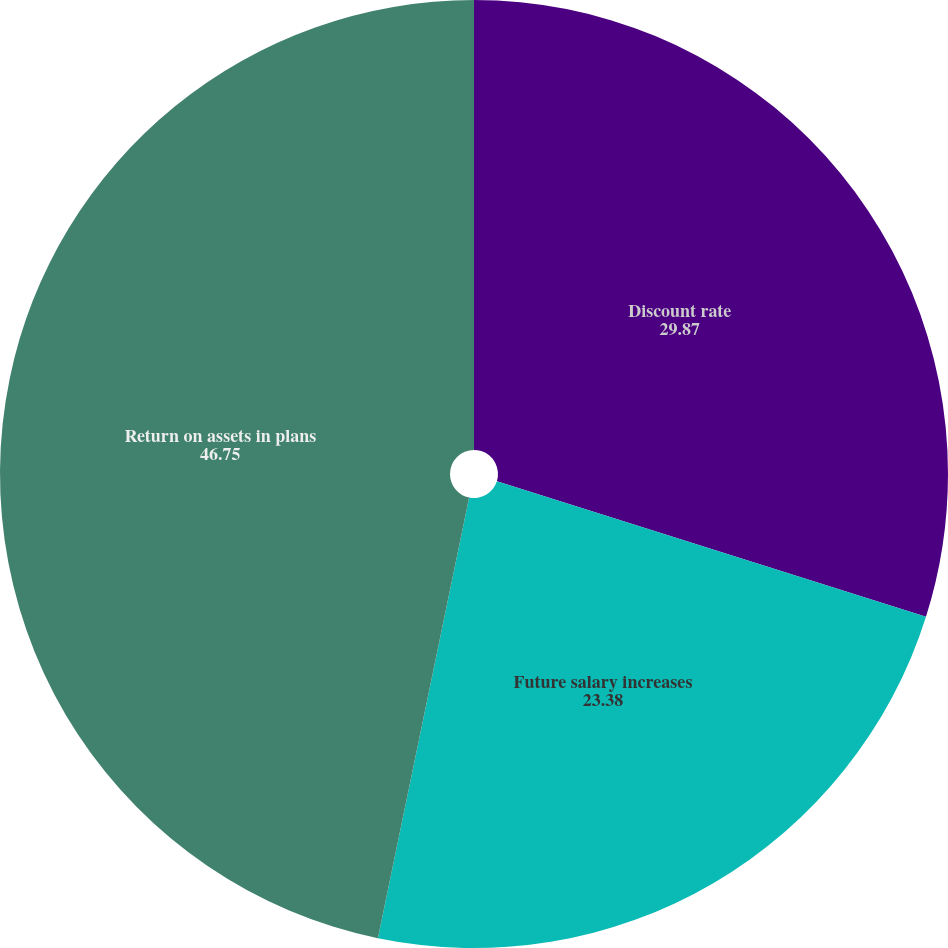Convert chart to OTSL. <chart><loc_0><loc_0><loc_500><loc_500><pie_chart><fcel>Discount rate<fcel>Future salary increases<fcel>Return on assets in plans<nl><fcel>29.87%<fcel>23.38%<fcel>46.75%<nl></chart> 